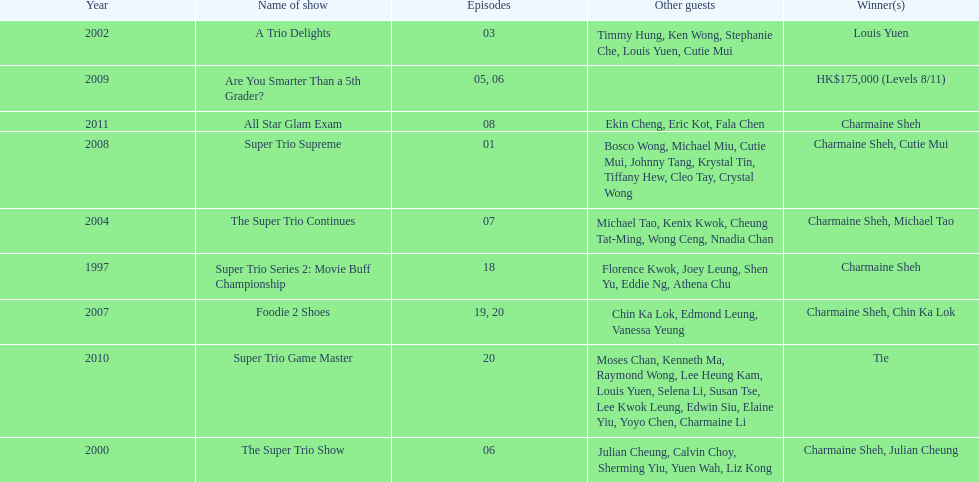What is the number of tv shows that charmaine sheh has appeared on? 9. Could you help me parse every detail presented in this table? {'header': ['Year', 'Name of show', 'Episodes', 'Other guests', 'Winner(s)'], 'rows': [['2002', 'A Trio Delights', '03', 'Timmy Hung, Ken Wong, Stephanie Che, Louis Yuen, Cutie Mui', 'Louis Yuen'], ['2009', 'Are You Smarter Than a 5th Grader?', '05, 06', '', 'HK$175,000 (Levels 8/11)'], ['2011', 'All Star Glam Exam', '08', 'Ekin Cheng, Eric Kot, Fala Chen', 'Charmaine Sheh'], ['2008', 'Super Trio Supreme', '01', 'Bosco Wong, Michael Miu, Cutie Mui, Johnny Tang, Krystal Tin, Tiffany Hew, Cleo Tay, Crystal Wong', 'Charmaine Sheh, Cutie Mui'], ['2004', 'The Super Trio Continues', '07', 'Michael Tao, Kenix Kwok, Cheung Tat-Ming, Wong Ceng, Nnadia Chan', 'Charmaine Sheh, Michael Tao'], ['1997', 'Super Trio Series 2: Movie Buff Championship', '18', 'Florence Kwok, Joey Leung, Shen Yu, Eddie Ng, Athena Chu', 'Charmaine Sheh'], ['2007', 'Foodie 2 Shoes', '19, 20', 'Chin Ka Lok, Edmond Leung, Vanessa Yeung', 'Charmaine Sheh, Chin Ka Lok'], ['2010', 'Super Trio Game Master', '20', 'Moses Chan, Kenneth Ma, Raymond Wong, Lee Heung Kam, Louis Yuen, Selena Li, Susan Tse, Lee Kwok Leung, Edwin Siu, Elaine Yiu, Yoyo Chen, Charmaine Li', 'Tie'], ['2000', 'The Super Trio Show', '06', 'Julian Cheung, Calvin Choy, Sherming Yiu, Yuen Wah, Liz Kong', 'Charmaine Sheh, Julian Cheung']]} 